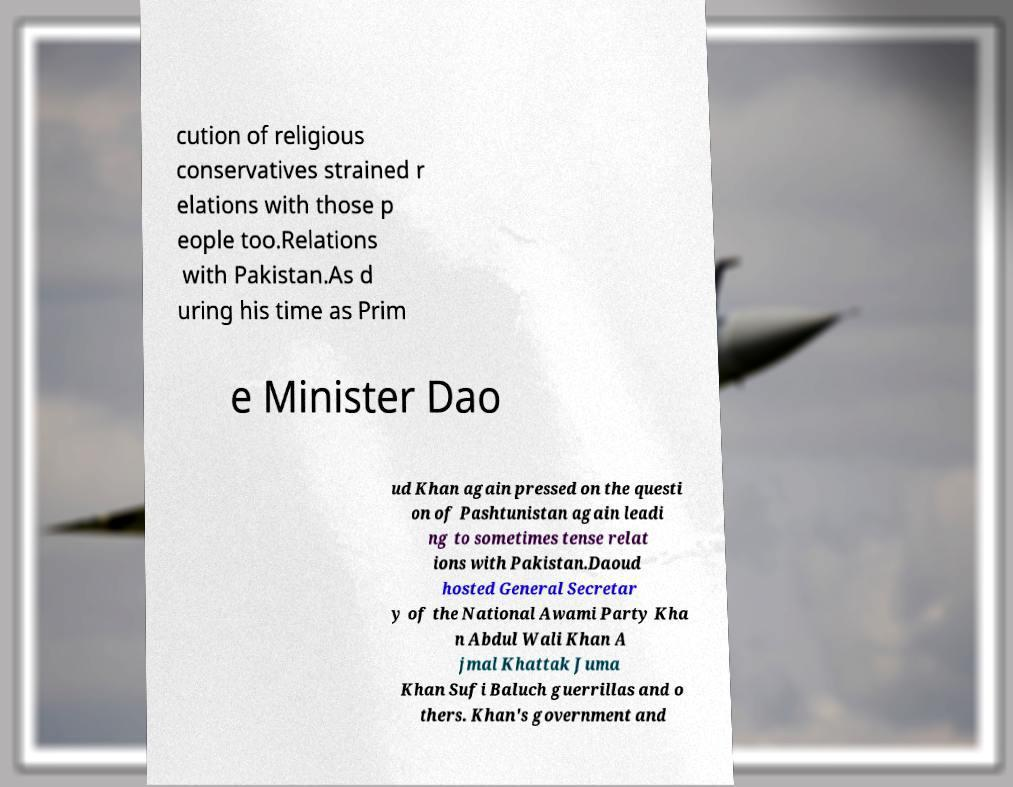What messages or text are displayed in this image? I need them in a readable, typed format. cution of religious conservatives strained r elations with those p eople too.Relations with Pakistan.As d uring his time as Prim e Minister Dao ud Khan again pressed on the questi on of Pashtunistan again leadi ng to sometimes tense relat ions with Pakistan.Daoud hosted General Secretar y of the National Awami Party Kha n Abdul Wali Khan A jmal Khattak Juma Khan Sufi Baluch guerrillas and o thers. Khan's government and 